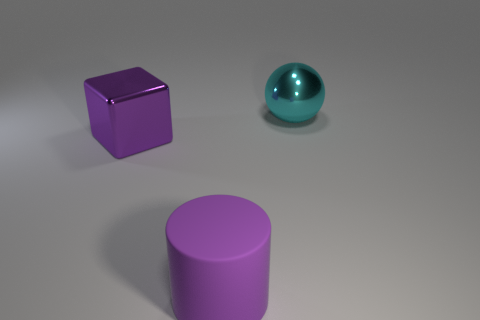What number of cyan balls are behind the purple block?
Give a very brief answer. 1. Is there a block made of the same material as the big cyan object?
Make the answer very short. Yes. The big object that is the same color as the large rubber cylinder is what shape?
Make the answer very short. Cube. What is the color of the metal thing that is behind the big purple shiny block?
Your response must be concise. Cyan. Are there the same number of big purple things that are to the left of the large rubber object and balls on the left side of the big cyan object?
Your answer should be very brief. No. What is the material of the big purple object to the right of the large shiny thing to the left of the purple matte thing?
Keep it short and to the point. Rubber. What number of things are either brown shiny things or large purple things behind the big rubber object?
Make the answer very short. 1. What is the size of the cube that is the same material as the cyan ball?
Provide a short and direct response. Large. Are there more large objects in front of the cube than large cyan things?
Make the answer very short. No. There is a object that is behind the big cylinder and on the left side of the cyan metal object; what is its size?
Offer a terse response. Large. 